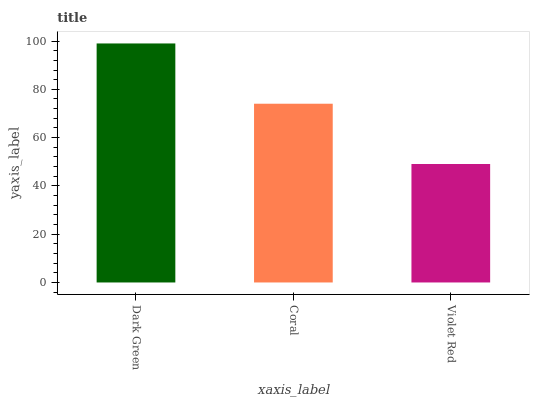Is Coral the minimum?
Answer yes or no. No. Is Coral the maximum?
Answer yes or no. No. Is Dark Green greater than Coral?
Answer yes or no. Yes. Is Coral less than Dark Green?
Answer yes or no. Yes. Is Coral greater than Dark Green?
Answer yes or no. No. Is Dark Green less than Coral?
Answer yes or no. No. Is Coral the high median?
Answer yes or no. Yes. Is Coral the low median?
Answer yes or no. Yes. Is Violet Red the high median?
Answer yes or no. No. Is Violet Red the low median?
Answer yes or no. No. 